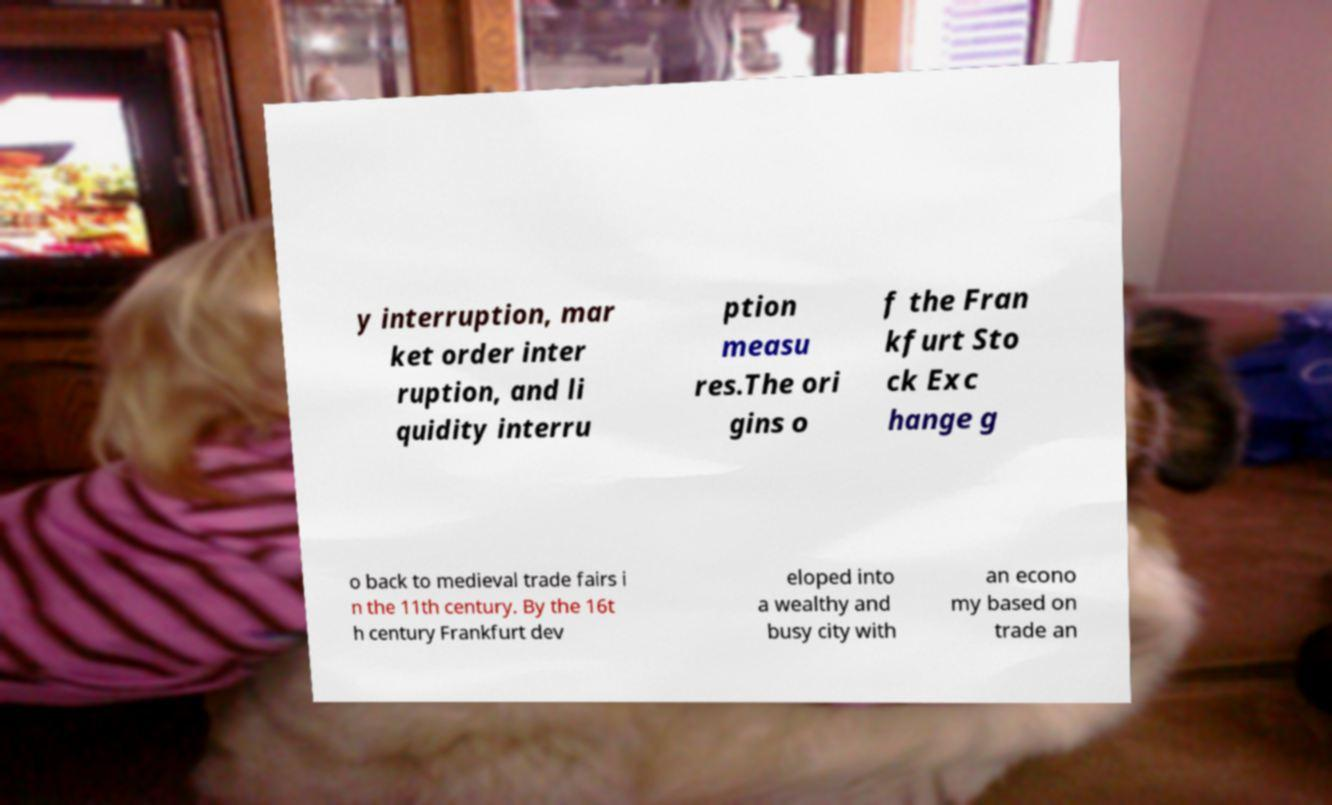Please read and relay the text visible in this image. What does it say? y interruption, mar ket order inter ruption, and li quidity interru ption measu res.The ori gins o f the Fran kfurt Sto ck Exc hange g o back to medieval trade fairs i n the 11th century. By the 16t h century Frankfurt dev eloped into a wealthy and busy city with an econo my based on trade an 